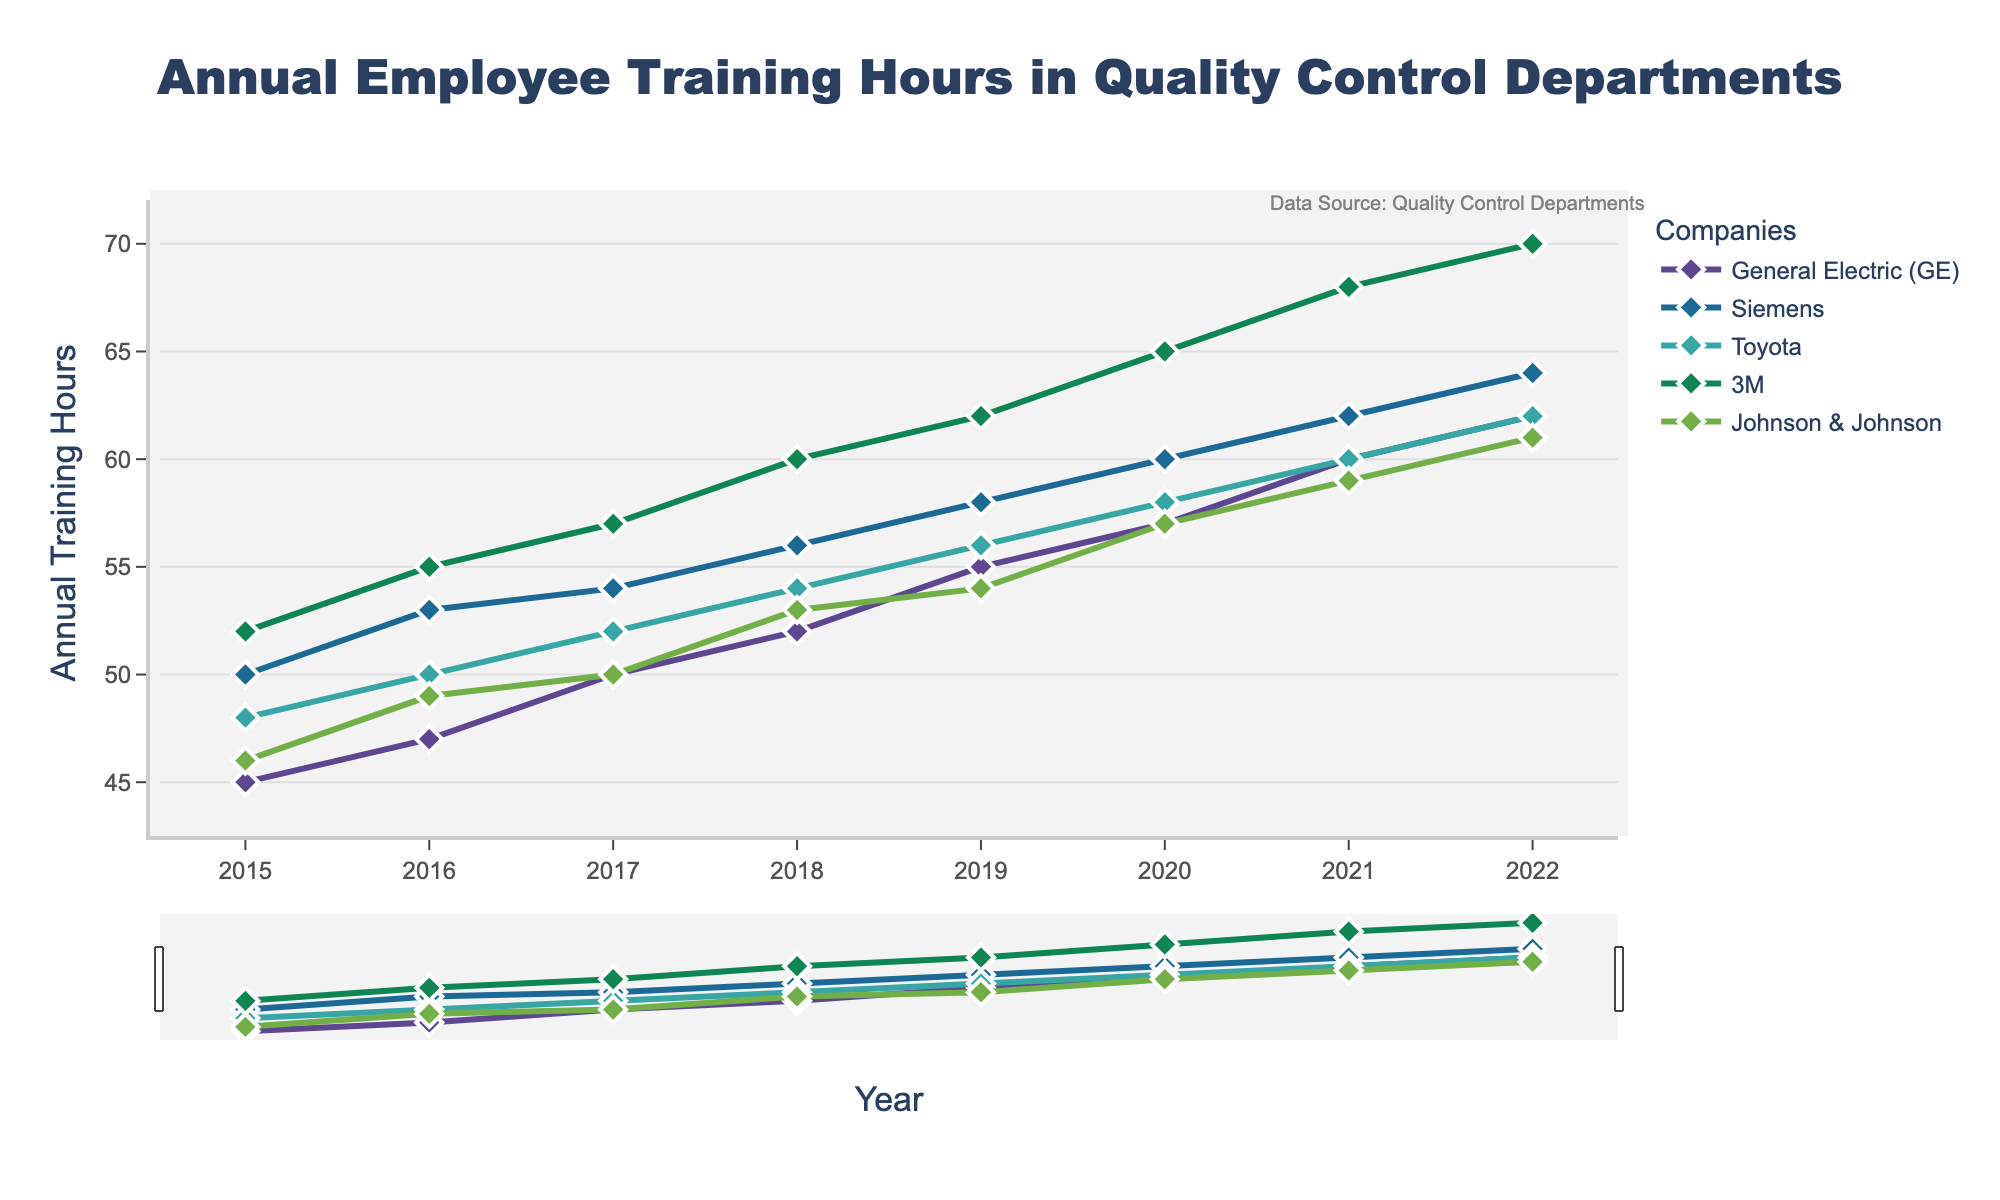What is the title of the figure? The title of the figure is usually displayed prominently at the top. In this case, we can find it by looking at the top-middle section.
Answer: Annual Employee Training Hours in Quality Control Departments What is the range of years displayed in the plot? The x-axis of the figure shows the range of years. By examining this axis, we can observe the starting year and the ending year.
Answer: 2015 to 2022 How many companies are represented in the figure? The legend to the right or bottom of the figure typically lists all the companies with their respective colors and markers. Counting these will provide the number of companies.
Answer: 5 Which company had the highest annual training hours in 2022? By looking at the data points for each company in the year 2022 on the x-axis, we can identify which company has the highest y-value (annual training hours).
Answer: 3M What was the trend of training hours for General Electric (GE) from 2015 to 2022? By tracing the line associated with General Electric (GE) from 2015 to 2022, we can observe the general direction and changes in the training hours over these years.
Answer: Increasing Which year showed a notable increase in training hours for Johnson & Johnson? By examining Johnson & Johnson's line, we can identify a year where there is a sharp upward slope, indicating a notable increase in training hours.
Answer: 2020 Compare the annual training hours between Siemens and Toyota in 2017. Which company had more, and by how much? Locate the points for both Siemens and Toyota in 2017. Siemens has 54 hours, and Toyota has 52 hours. Subtract Toyota's hours from Siemens's hours.
Answer: Siemens had 2 more hours What is the average annual training hours for 3M from 2015 to 2022? Sum all the annual training hours for 3M from 2015 to 2022, then divide by the number of years (8). The years' values are 52 + 55 + 57 + 60 + 62 + 65 + 68 + 70 = 489. Dividing by 8 gives 61.125.
Answer: 61.125 Do any companies have similar trends in the change of training hours over the observed years? By visually inspecting the lines representing different companies, determine if any lines have similar slopes and changes, indicating similar trends.
Answer: Siemens and Toyota Which company showed the least variability in training hours from 2015 to 2022? By observing the smoothness and steep changes in each company's line, we can identify the company with the least fluctuations.
Answer: Johnson & Johnson 